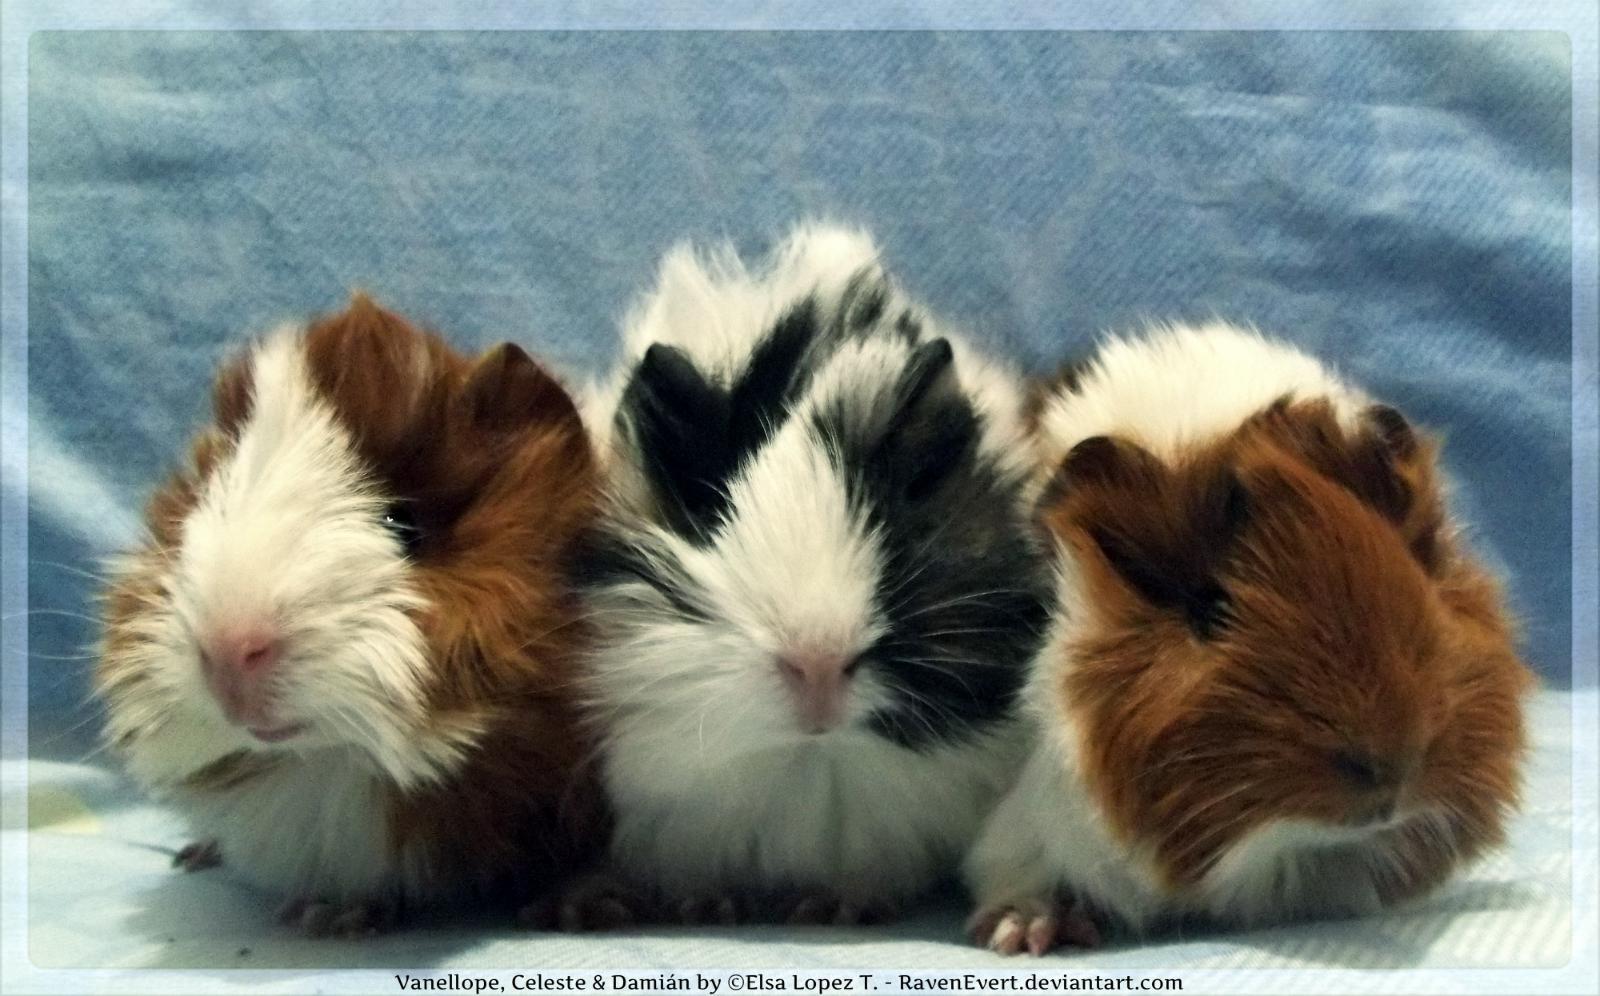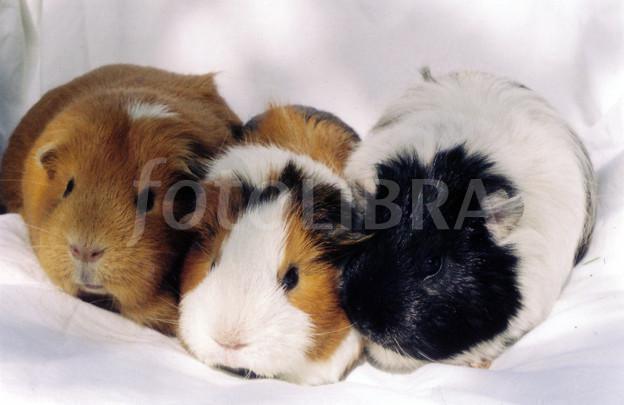The first image is the image on the left, the second image is the image on the right. Considering the images on both sides, is "One image shows a horizontal row of five guinea pigs." valid? Answer yes or no. No. The first image is the image on the left, the second image is the image on the right. For the images displayed, is the sentence "The right image contains exactly five guinea pigs in a horizontal row." factually correct? Answer yes or no. No. 